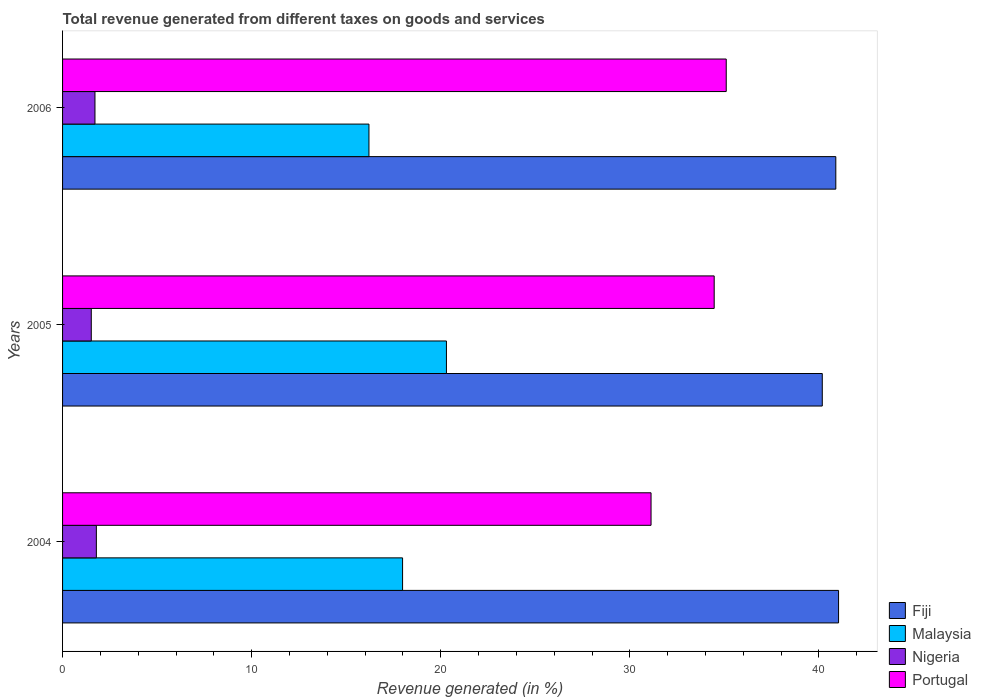How many groups of bars are there?
Ensure brevity in your answer.  3. How many bars are there on the 1st tick from the top?
Ensure brevity in your answer.  4. What is the label of the 1st group of bars from the top?
Your response must be concise. 2006. In how many cases, is the number of bars for a given year not equal to the number of legend labels?
Ensure brevity in your answer.  0. What is the total revenue generated in Portugal in 2006?
Offer a terse response. 35.1. Across all years, what is the maximum total revenue generated in Fiji?
Give a very brief answer. 41.04. Across all years, what is the minimum total revenue generated in Nigeria?
Your response must be concise. 1.52. In which year was the total revenue generated in Portugal maximum?
Ensure brevity in your answer.  2006. In which year was the total revenue generated in Malaysia minimum?
Offer a terse response. 2006. What is the total total revenue generated in Fiji in the graph?
Give a very brief answer. 122.11. What is the difference between the total revenue generated in Nigeria in 2004 and that in 2005?
Offer a terse response. 0.27. What is the difference between the total revenue generated in Portugal in 2004 and the total revenue generated in Nigeria in 2006?
Offer a terse response. 29.41. What is the average total revenue generated in Portugal per year?
Your response must be concise. 33.56. In the year 2004, what is the difference between the total revenue generated in Fiji and total revenue generated in Nigeria?
Make the answer very short. 39.25. What is the ratio of the total revenue generated in Portugal in 2005 to that in 2006?
Give a very brief answer. 0.98. Is the difference between the total revenue generated in Fiji in 2004 and 2005 greater than the difference between the total revenue generated in Nigeria in 2004 and 2005?
Provide a succinct answer. Yes. What is the difference between the highest and the second highest total revenue generated in Portugal?
Provide a succinct answer. 0.64. What is the difference between the highest and the lowest total revenue generated in Fiji?
Keep it short and to the point. 0.86. What does the 3rd bar from the top in 2006 represents?
Give a very brief answer. Malaysia. Is it the case that in every year, the sum of the total revenue generated in Nigeria and total revenue generated in Fiji is greater than the total revenue generated in Portugal?
Make the answer very short. Yes. What is the difference between two consecutive major ticks on the X-axis?
Keep it short and to the point. 10. How many legend labels are there?
Your answer should be very brief. 4. What is the title of the graph?
Keep it short and to the point. Total revenue generated from different taxes on goods and services. What is the label or title of the X-axis?
Offer a very short reply. Revenue generated (in %). What is the label or title of the Y-axis?
Make the answer very short. Years. What is the Revenue generated (in %) in Fiji in 2004?
Offer a very short reply. 41.04. What is the Revenue generated (in %) of Malaysia in 2004?
Offer a terse response. 17.98. What is the Revenue generated (in %) of Nigeria in 2004?
Keep it short and to the point. 1.79. What is the Revenue generated (in %) in Portugal in 2004?
Keep it short and to the point. 31.12. What is the Revenue generated (in %) in Fiji in 2005?
Your answer should be very brief. 40.18. What is the Revenue generated (in %) of Malaysia in 2005?
Provide a succinct answer. 20.3. What is the Revenue generated (in %) in Nigeria in 2005?
Offer a terse response. 1.52. What is the Revenue generated (in %) in Portugal in 2005?
Provide a short and direct response. 34.46. What is the Revenue generated (in %) of Fiji in 2006?
Your answer should be compact. 40.89. What is the Revenue generated (in %) in Malaysia in 2006?
Your response must be concise. 16.2. What is the Revenue generated (in %) of Nigeria in 2006?
Offer a terse response. 1.71. What is the Revenue generated (in %) of Portugal in 2006?
Provide a succinct answer. 35.1. Across all years, what is the maximum Revenue generated (in %) in Fiji?
Provide a succinct answer. 41.04. Across all years, what is the maximum Revenue generated (in %) of Malaysia?
Ensure brevity in your answer.  20.3. Across all years, what is the maximum Revenue generated (in %) of Nigeria?
Your response must be concise. 1.79. Across all years, what is the maximum Revenue generated (in %) of Portugal?
Make the answer very short. 35.1. Across all years, what is the minimum Revenue generated (in %) of Fiji?
Keep it short and to the point. 40.18. Across all years, what is the minimum Revenue generated (in %) of Malaysia?
Your answer should be very brief. 16.2. Across all years, what is the minimum Revenue generated (in %) in Nigeria?
Your answer should be very brief. 1.52. Across all years, what is the minimum Revenue generated (in %) of Portugal?
Offer a very short reply. 31.12. What is the total Revenue generated (in %) of Fiji in the graph?
Provide a succinct answer. 122.11. What is the total Revenue generated (in %) in Malaysia in the graph?
Give a very brief answer. 54.48. What is the total Revenue generated (in %) of Nigeria in the graph?
Your answer should be very brief. 5.02. What is the total Revenue generated (in %) in Portugal in the graph?
Provide a short and direct response. 100.68. What is the difference between the Revenue generated (in %) in Fiji in 2004 and that in 2005?
Offer a very short reply. 0.86. What is the difference between the Revenue generated (in %) of Malaysia in 2004 and that in 2005?
Offer a very short reply. -2.32. What is the difference between the Revenue generated (in %) of Nigeria in 2004 and that in 2005?
Offer a terse response. 0.27. What is the difference between the Revenue generated (in %) in Portugal in 2004 and that in 2005?
Your answer should be compact. -3.34. What is the difference between the Revenue generated (in %) of Fiji in 2004 and that in 2006?
Offer a very short reply. 0.15. What is the difference between the Revenue generated (in %) in Malaysia in 2004 and that in 2006?
Your answer should be very brief. 1.78. What is the difference between the Revenue generated (in %) of Nigeria in 2004 and that in 2006?
Your answer should be very brief. 0.07. What is the difference between the Revenue generated (in %) in Portugal in 2004 and that in 2006?
Keep it short and to the point. -3.98. What is the difference between the Revenue generated (in %) of Fiji in 2005 and that in 2006?
Keep it short and to the point. -0.72. What is the difference between the Revenue generated (in %) of Malaysia in 2005 and that in 2006?
Keep it short and to the point. 4.1. What is the difference between the Revenue generated (in %) in Nigeria in 2005 and that in 2006?
Make the answer very short. -0.2. What is the difference between the Revenue generated (in %) in Portugal in 2005 and that in 2006?
Make the answer very short. -0.64. What is the difference between the Revenue generated (in %) of Fiji in 2004 and the Revenue generated (in %) of Malaysia in 2005?
Offer a terse response. 20.74. What is the difference between the Revenue generated (in %) in Fiji in 2004 and the Revenue generated (in %) in Nigeria in 2005?
Provide a succinct answer. 39.52. What is the difference between the Revenue generated (in %) in Fiji in 2004 and the Revenue generated (in %) in Portugal in 2005?
Provide a short and direct response. 6.58. What is the difference between the Revenue generated (in %) in Malaysia in 2004 and the Revenue generated (in %) in Nigeria in 2005?
Offer a terse response. 16.46. What is the difference between the Revenue generated (in %) of Malaysia in 2004 and the Revenue generated (in %) of Portugal in 2005?
Your answer should be very brief. -16.48. What is the difference between the Revenue generated (in %) in Nigeria in 2004 and the Revenue generated (in %) in Portugal in 2005?
Ensure brevity in your answer.  -32.67. What is the difference between the Revenue generated (in %) in Fiji in 2004 and the Revenue generated (in %) in Malaysia in 2006?
Offer a very short reply. 24.84. What is the difference between the Revenue generated (in %) of Fiji in 2004 and the Revenue generated (in %) of Nigeria in 2006?
Offer a very short reply. 39.32. What is the difference between the Revenue generated (in %) of Fiji in 2004 and the Revenue generated (in %) of Portugal in 2006?
Make the answer very short. 5.94. What is the difference between the Revenue generated (in %) in Malaysia in 2004 and the Revenue generated (in %) in Nigeria in 2006?
Ensure brevity in your answer.  16.27. What is the difference between the Revenue generated (in %) of Malaysia in 2004 and the Revenue generated (in %) of Portugal in 2006?
Provide a succinct answer. -17.12. What is the difference between the Revenue generated (in %) in Nigeria in 2004 and the Revenue generated (in %) in Portugal in 2006?
Your response must be concise. -33.31. What is the difference between the Revenue generated (in %) of Fiji in 2005 and the Revenue generated (in %) of Malaysia in 2006?
Your answer should be compact. 23.97. What is the difference between the Revenue generated (in %) in Fiji in 2005 and the Revenue generated (in %) in Nigeria in 2006?
Give a very brief answer. 38.46. What is the difference between the Revenue generated (in %) in Fiji in 2005 and the Revenue generated (in %) in Portugal in 2006?
Your answer should be very brief. 5.08. What is the difference between the Revenue generated (in %) of Malaysia in 2005 and the Revenue generated (in %) of Nigeria in 2006?
Your response must be concise. 18.59. What is the difference between the Revenue generated (in %) of Malaysia in 2005 and the Revenue generated (in %) of Portugal in 2006?
Provide a succinct answer. -14.8. What is the difference between the Revenue generated (in %) in Nigeria in 2005 and the Revenue generated (in %) in Portugal in 2006?
Provide a short and direct response. -33.58. What is the average Revenue generated (in %) of Fiji per year?
Your answer should be compact. 40.7. What is the average Revenue generated (in %) of Malaysia per year?
Your response must be concise. 18.16. What is the average Revenue generated (in %) in Nigeria per year?
Provide a succinct answer. 1.67. What is the average Revenue generated (in %) of Portugal per year?
Your response must be concise. 33.56. In the year 2004, what is the difference between the Revenue generated (in %) in Fiji and Revenue generated (in %) in Malaysia?
Give a very brief answer. 23.06. In the year 2004, what is the difference between the Revenue generated (in %) in Fiji and Revenue generated (in %) in Nigeria?
Your response must be concise. 39.25. In the year 2004, what is the difference between the Revenue generated (in %) of Fiji and Revenue generated (in %) of Portugal?
Ensure brevity in your answer.  9.92. In the year 2004, what is the difference between the Revenue generated (in %) of Malaysia and Revenue generated (in %) of Nigeria?
Your response must be concise. 16.19. In the year 2004, what is the difference between the Revenue generated (in %) in Malaysia and Revenue generated (in %) in Portugal?
Keep it short and to the point. -13.14. In the year 2004, what is the difference between the Revenue generated (in %) of Nigeria and Revenue generated (in %) of Portugal?
Make the answer very short. -29.33. In the year 2005, what is the difference between the Revenue generated (in %) of Fiji and Revenue generated (in %) of Malaysia?
Keep it short and to the point. 19.88. In the year 2005, what is the difference between the Revenue generated (in %) of Fiji and Revenue generated (in %) of Nigeria?
Your answer should be very brief. 38.66. In the year 2005, what is the difference between the Revenue generated (in %) of Fiji and Revenue generated (in %) of Portugal?
Offer a very short reply. 5.72. In the year 2005, what is the difference between the Revenue generated (in %) in Malaysia and Revenue generated (in %) in Nigeria?
Provide a succinct answer. 18.78. In the year 2005, what is the difference between the Revenue generated (in %) in Malaysia and Revenue generated (in %) in Portugal?
Make the answer very short. -14.16. In the year 2005, what is the difference between the Revenue generated (in %) in Nigeria and Revenue generated (in %) in Portugal?
Make the answer very short. -32.94. In the year 2006, what is the difference between the Revenue generated (in %) of Fiji and Revenue generated (in %) of Malaysia?
Provide a succinct answer. 24.69. In the year 2006, what is the difference between the Revenue generated (in %) in Fiji and Revenue generated (in %) in Nigeria?
Give a very brief answer. 39.18. In the year 2006, what is the difference between the Revenue generated (in %) of Fiji and Revenue generated (in %) of Portugal?
Make the answer very short. 5.79. In the year 2006, what is the difference between the Revenue generated (in %) of Malaysia and Revenue generated (in %) of Nigeria?
Ensure brevity in your answer.  14.49. In the year 2006, what is the difference between the Revenue generated (in %) in Malaysia and Revenue generated (in %) in Portugal?
Keep it short and to the point. -18.89. In the year 2006, what is the difference between the Revenue generated (in %) in Nigeria and Revenue generated (in %) in Portugal?
Give a very brief answer. -33.38. What is the ratio of the Revenue generated (in %) of Fiji in 2004 to that in 2005?
Your answer should be compact. 1.02. What is the ratio of the Revenue generated (in %) of Malaysia in 2004 to that in 2005?
Your answer should be compact. 0.89. What is the ratio of the Revenue generated (in %) of Nigeria in 2004 to that in 2005?
Your answer should be compact. 1.18. What is the ratio of the Revenue generated (in %) in Portugal in 2004 to that in 2005?
Your response must be concise. 0.9. What is the ratio of the Revenue generated (in %) in Malaysia in 2004 to that in 2006?
Make the answer very short. 1.11. What is the ratio of the Revenue generated (in %) in Nigeria in 2004 to that in 2006?
Provide a succinct answer. 1.04. What is the ratio of the Revenue generated (in %) in Portugal in 2004 to that in 2006?
Give a very brief answer. 0.89. What is the ratio of the Revenue generated (in %) in Fiji in 2005 to that in 2006?
Ensure brevity in your answer.  0.98. What is the ratio of the Revenue generated (in %) of Malaysia in 2005 to that in 2006?
Provide a succinct answer. 1.25. What is the ratio of the Revenue generated (in %) of Nigeria in 2005 to that in 2006?
Give a very brief answer. 0.89. What is the ratio of the Revenue generated (in %) in Portugal in 2005 to that in 2006?
Offer a terse response. 0.98. What is the difference between the highest and the second highest Revenue generated (in %) of Fiji?
Offer a terse response. 0.15. What is the difference between the highest and the second highest Revenue generated (in %) in Malaysia?
Offer a very short reply. 2.32. What is the difference between the highest and the second highest Revenue generated (in %) of Nigeria?
Offer a very short reply. 0.07. What is the difference between the highest and the second highest Revenue generated (in %) of Portugal?
Your answer should be compact. 0.64. What is the difference between the highest and the lowest Revenue generated (in %) of Fiji?
Your response must be concise. 0.86. What is the difference between the highest and the lowest Revenue generated (in %) of Malaysia?
Give a very brief answer. 4.1. What is the difference between the highest and the lowest Revenue generated (in %) of Nigeria?
Ensure brevity in your answer.  0.27. What is the difference between the highest and the lowest Revenue generated (in %) in Portugal?
Ensure brevity in your answer.  3.98. 